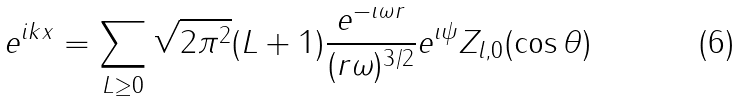Convert formula to latex. <formula><loc_0><loc_0><loc_500><loc_500>e ^ { i k x } = \sum _ { L \geq 0 } \sqrt { 2 \pi ^ { 2 } } ( L + 1 ) \frac { e ^ { - \imath \omega r } } { ( r \omega ) ^ { 3 / 2 } } e ^ { \imath \psi } Z _ { l , 0 } ( \cos \theta )</formula> 